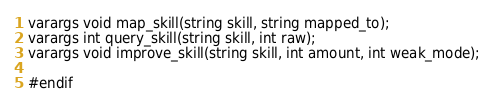<code> <loc_0><loc_0><loc_500><loc_500><_C_>varargs void map_skill(string skill, string mapped_to);
varargs int query_skill(string skill, int raw);
varargs void improve_skill(string skill, int amount, int weak_mode);

#endif
</code> 